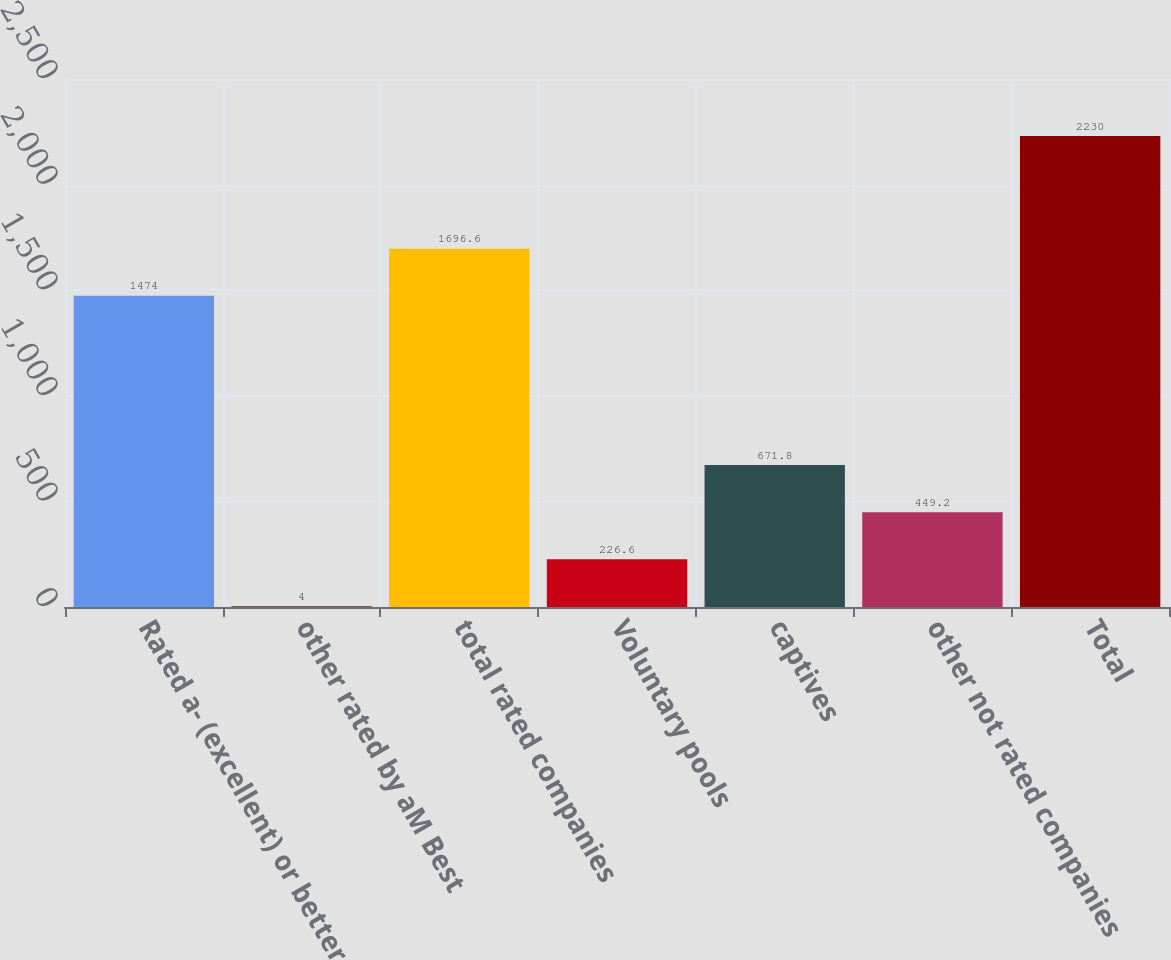Convert chart. <chart><loc_0><loc_0><loc_500><loc_500><bar_chart><fcel>Rated a- (excellent) or better<fcel>other rated by aM Best<fcel>total rated companies<fcel>Voluntary pools<fcel>captives<fcel>other not rated companies<fcel>Total<nl><fcel>1474<fcel>4<fcel>1696.6<fcel>226.6<fcel>671.8<fcel>449.2<fcel>2230<nl></chart> 